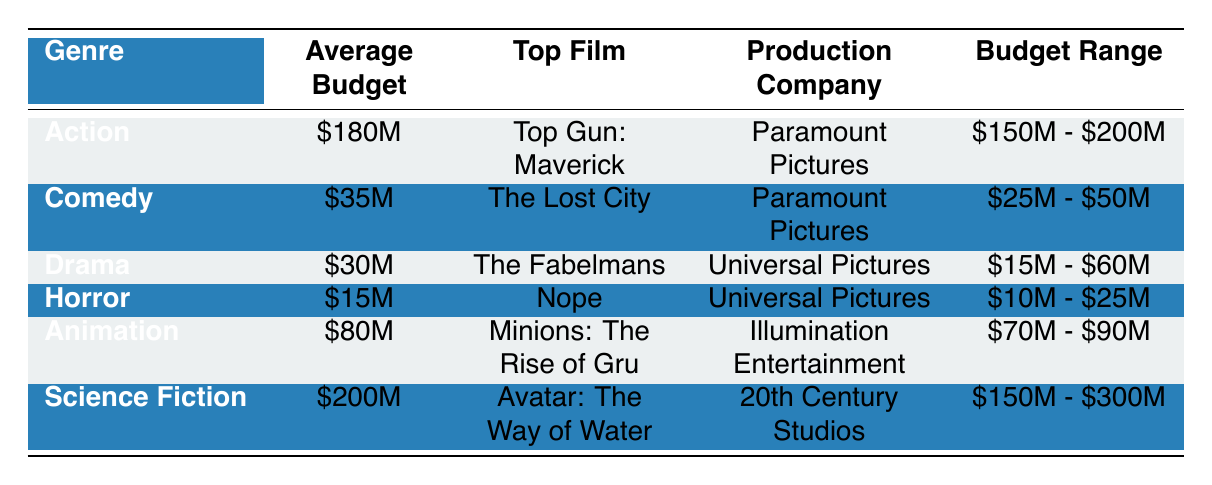What is the average budget for the Action genre? The table shows that the average budget for the Action genre is listed as 180 million dollars.
Answer: 180 million dollars What is the top film for the Comedy genre? The table indicates that the top film for the Comedy genre is "The Lost City."
Answer: The Lost City Which production company made "Avatar: The Way of Water"? According to the table, "Avatar: The Way of Water" was produced by 20th Century Studios.
Answer: 20th Century Studios Is the average budget for Animation higher than that for Drama? The average budget for Animation is 80 million dollars, while Drama's average is 30 million dollars. Since 80 million is greater than 30 million, the statement is true.
Answer: Yes What is the total average budget of the Horror and Drama genres combined? The average budget for Horror is 15 million dollars and for Drama is 30 million dollars. Adding these, 15 + 30 equals 45 million dollars.
Answer: 45 million dollars Which genre has the widest budget range? By examining the budget ranges, Science Fiction spans from 150 million to 300 million dollars, showing a range of 150 million dollars, which is wider than the other genres.
Answer: Science Fiction Are all top films produced by Universal Pictures? The top films listed show that both Comedy and Horror genres are produced by Paramount Pictures, so not all top films are produced by Universal Pictures.
Answer: No What is the difference in average budget between the Action and Comedy genres? The average budget for Action is 180 million dollars and for Comedy it is 35 million dollars. The difference is 180 - 35, which equals 145 million dollars.
Answer: 145 million dollars Which genre has the lowest budget allocation and what is its average budget? The table indicates that Horror has the lowest average budget of 15 million dollars among all genres listed.
Answer: Horror, 15 million dollars 